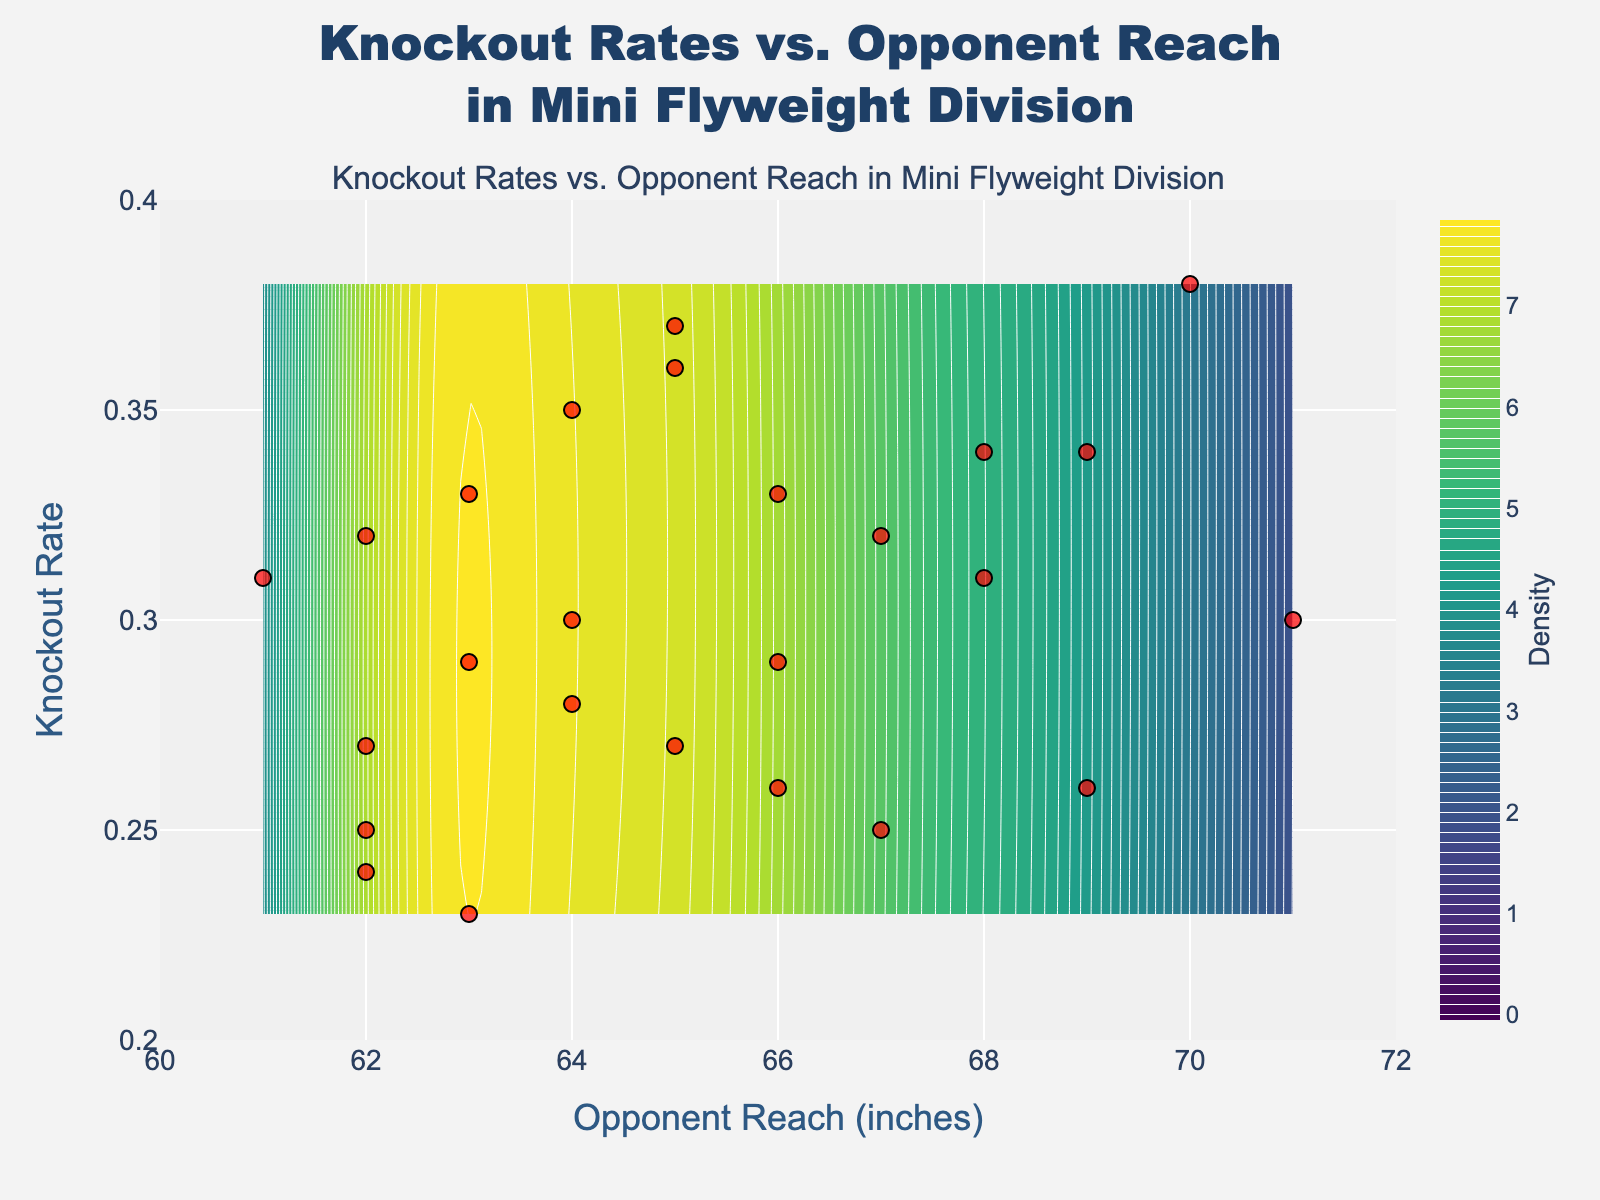How many data points are shown in the scatter plot? Count the red markers scattered across the plot. Visually, there are 25 red markers representing data points.
Answer: 25 What is the color scale used for the contour plot? Refer to the gradient of colors in the contour plot. It starts from dark violet to vibrant yellow. This corresponds to the 'Viridis' color scale often used in contour plots.
Answer: Viridis What is the title of the plot? Look at the text at the very top of the plot which describes its purpose. The title reads "Knockout Rates vs. Opponent Reach in Mini Flyweight Division".
Answer: Knockout Rates vs. Opponent Reach in Mini Flyweight Division What ranges are used for the x-axis and y-axis? Observe the labels at the bottom and left of the plot. The x-axis (Opponent Reach) ranges from 60 to 72 inches, and the y-axis (Knockout Rate) ranges from 0.2 to 0.4.
Answer: Opponent Reach: 60 to 72, Knockout Rate: 0.2 to 0.4 Where is the highest density of data points located in the contour plot? Look for the region where the contours are most tightly packed and the color is closest to yellow. The highest density is around an opponent reach of 65 inches and a knockout rate of 0.29 - 0.32.
Answer: Around (65, 0.29-0.32) How does the knockout rate trend with increasing opponent reach based on the scatter plot? Observe the direction in which the scatter points trend. Generally speaking, as the opponent reach increases from 60 to 72, the knockout rate seems to rise slightly but there's some variability.
Answer: Slightly increases with variability Which opponent reach has the highest recorded knockout rate? Identify the tallest y-coordinate among the scatter points. The tallest point aligns with an opponent reach of 70 inches, and the knockout rate for this point is 0.38.
Answer: 70 inches What is the average opponent reach of all the data points shown? Sum up all the opponent reach values and divide by the number of data points. The calculation is (62 + 64 + 63 + 65 + 66 + 64 + 67 + 63 + 61 + 68 + 62 + 69 + 65 + 66 + 62 + 67 + 70 + 71 + 68 + 63 + 64 + 66 + 65 + 62 + 69)/25 = 65.04.
Answer: 65.04 inches Compare the average knockout rate for data points with opponent reach less than and greater than 65 inches. Separate the data points into two groups based on the condition. Calculate the average knockout rate for each group. For opponent reach < 65: (0.25+0.29+0.28+0.23+0.31+0.27+0.26+0.30+0.25+0.32+0.33)/11 ≈ 0.283. For opponent reach > 65: (0.33+0.36+0.32+0.34+0.26+0.34+0.37+0.29+0.24+0.38+0.31+0.31)/13 ≈ 0.317. Thus, the knockout rate increases slightly with opponent reach.
Answer: Less than 65: 0.283, Greater than 65: 0.317 